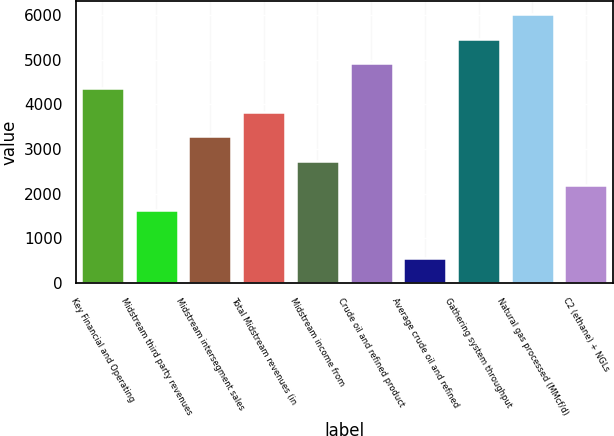Convert chart to OTSL. <chart><loc_0><loc_0><loc_500><loc_500><bar_chart><fcel>Key Financial and Operating<fcel>Midstream third party revenues<fcel>Midstream intersegment sales<fcel>Total Midstream revenues (in<fcel>Midstream income from<fcel>Crude oil and refined product<fcel>Average crude oil and refined<fcel>Gathering system throughput<fcel>Natural gas processed (MMcf/d)<fcel>C2 (ethane) + NGLs<nl><fcel>4374.48<fcel>1640.68<fcel>3280.96<fcel>3827.72<fcel>2734.2<fcel>4921.24<fcel>547.16<fcel>5468<fcel>6014.76<fcel>2187.44<nl></chart> 